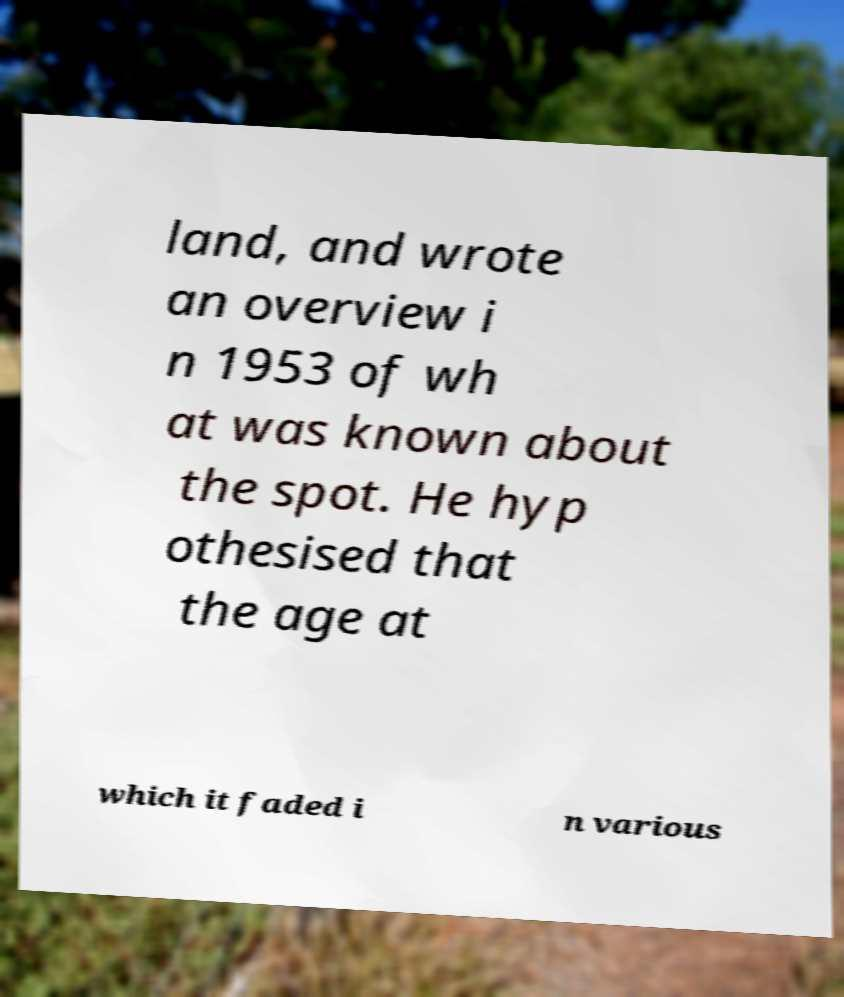Please read and relay the text visible in this image. What does it say? land, and wrote an overview i n 1953 of wh at was known about the spot. He hyp othesised that the age at which it faded i n various 